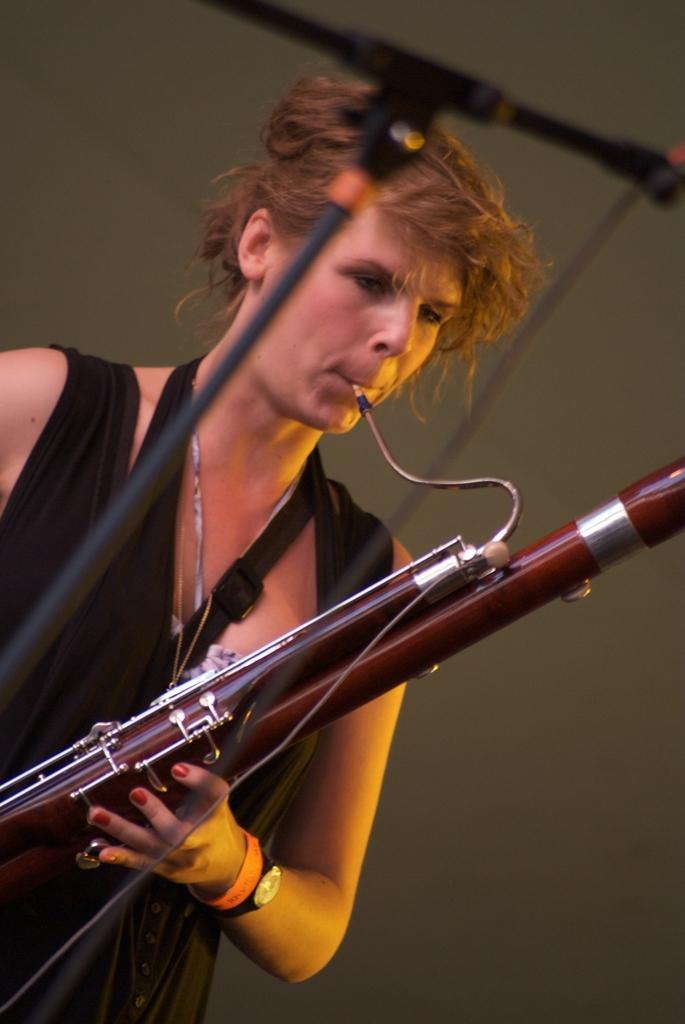What is the main subject of the image? There is a beautiful woman in the image. What is the woman doing in the image? The woman is playing a musical instrument. What color is the dress the woman is wearing? The woman is wearing a black dress. How does the woman set off the alarm in the image? There is no alarm present in the image, so the woman cannot set it off. 